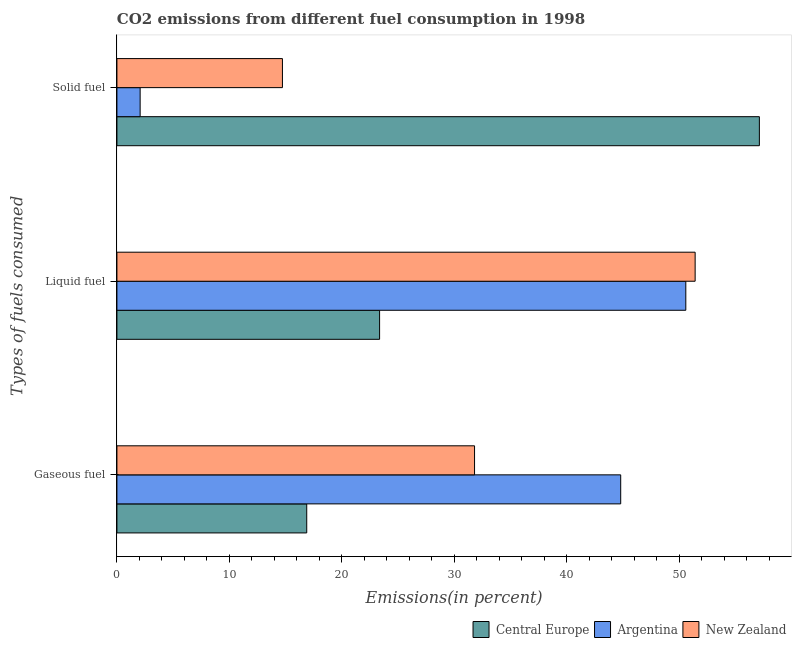How many different coloured bars are there?
Provide a succinct answer. 3. How many groups of bars are there?
Ensure brevity in your answer.  3. Are the number of bars on each tick of the Y-axis equal?
Keep it short and to the point. Yes. How many bars are there on the 1st tick from the top?
Provide a short and direct response. 3. How many bars are there on the 2nd tick from the bottom?
Provide a short and direct response. 3. What is the label of the 3rd group of bars from the top?
Your answer should be very brief. Gaseous fuel. What is the percentage of liquid fuel emission in Argentina?
Your answer should be compact. 50.58. Across all countries, what is the maximum percentage of gaseous fuel emission?
Your answer should be compact. 44.79. Across all countries, what is the minimum percentage of gaseous fuel emission?
Offer a very short reply. 16.88. In which country was the percentage of solid fuel emission minimum?
Offer a very short reply. Argentina. What is the total percentage of gaseous fuel emission in the graph?
Provide a short and direct response. 93.46. What is the difference between the percentage of solid fuel emission in New Zealand and that in Central Europe?
Your answer should be very brief. -42.4. What is the difference between the percentage of gaseous fuel emission in Argentina and the percentage of liquid fuel emission in Central Europe?
Offer a very short reply. 21.44. What is the average percentage of solid fuel emission per country?
Provide a succinct answer. 24.63. What is the difference between the percentage of gaseous fuel emission and percentage of liquid fuel emission in New Zealand?
Keep it short and to the point. -19.61. In how many countries, is the percentage of liquid fuel emission greater than 50 %?
Your response must be concise. 2. What is the ratio of the percentage of solid fuel emission in Central Europe to that in Argentina?
Offer a terse response. 27.67. Is the percentage of solid fuel emission in Argentina less than that in Central Europe?
Keep it short and to the point. Yes. Is the difference between the percentage of liquid fuel emission in Central Europe and Argentina greater than the difference between the percentage of solid fuel emission in Central Europe and Argentina?
Make the answer very short. No. What is the difference between the highest and the second highest percentage of solid fuel emission?
Make the answer very short. 42.4. What is the difference between the highest and the lowest percentage of gaseous fuel emission?
Your answer should be compact. 27.91. Is the sum of the percentage of solid fuel emission in Argentina and Central Europe greater than the maximum percentage of gaseous fuel emission across all countries?
Make the answer very short. Yes. How many bars are there?
Offer a very short reply. 9. Are the values on the major ticks of X-axis written in scientific E-notation?
Offer a very short reply. No. Where does the legend appear in the graph?
Give a very brief answer. Bottom right. How many legend labels are there?
Provide a short and direct response. 3. How are the legend labels stacked?
Give a very brief answer. Horizontal. What is the title of the graph?
Your answer should be compact. CO2 emissions from different fuel consumption in 1998. What is the label or title of the X-axis?
Make the answer very short. Emissions(in percent). What is the label or title of the Y-axis?
Your answer should be very brief. Types of fuels consumed. What is the Emissions(in percent) of Central Europe in Gaseous fuel?
Ensure brevity in your answer.  16.88. What is the Emissions(in percent) in Argentina in Gaseous fuel?
Make the answer very short. 44.79. What is the Emissions(in percent) of New Zealand in Gaseous fuel?
Keep it short and to the point. 31.79. What is the Emissions(in percent) of Central Europe in Liquid fuel?
Keep it short and to the point. 23.35. What is the Emissions(in percent) in Argentina in Liquid fuel?
Offer a terse response. 50.58. What is the Emissions(in percent) in New Zealand in Liquid fuel?
Ensure brevity in your answer.  51.41. What is the Emissions(in percent) of Central Europe in Solid fuel?
Your response must be concise. 57.12. What is the Emissions(in percent) of Argentina in Solid fuel?
Provide a short and direct response. 2.06. What is the Emissions(in percent) of New Zealand in Solid fuel?
Ensure brevity in your answer.  14.72. Across all Types of fuels consumed, what is the maximum Emissions(in percent) in Central Europe?
Give a very brief answer. 57.12. Across all Types of fuels consumed, what is the maximum Emissions(in percent) of Argentina?
Your answer should be very brief. 50.58. Across all Types of fuels consumed, what is the maximum Emissions(in percent) in New Zealand?
Provide a succinct answer. 51.41. Across all Types of fuels consumed, what is the minimum Emissions(in percent) in Central Europe?
Offer a very short reply. 16.88. Across all Types of fuels consumed, what is the minimum Emissions(in percent) of Argentina?
Offer a very short reply. 2.06. Across all Types of fuels consumed, what is the minimum Emissions(in percent) in New Zealand?
Provide a succinct answer. 14.72. What is the total Emissions(in percent) in Central Europe in the graph?
Provide a short and direct response. 97.35. What is the total Emissions(in percent) of Argentina in the graph?
Keep it short and to the point. 97.43. What is the total Emissions(in percent) in New Zealand in the graph?
Provide a succinct answer. 97.92. What is the difference between the Emissions(in percent) in Central Europe in Gaseous fuel and that in Liquid fuel?
Keep it short and to the point. -6.48. What is the difference between the Emissions(in percent) of Argentina in Gaseous fuel and that in Liquid fuel?
Give a very brief answer. -5.79. What is the difference between the Emissions(in percent) of New Zealand in Gaseous fuel and that in Liquid fuel?
Offer a terse response. -19.61. What is the difference between the Emissions(in percent) in Central Europe in Gaseous fuel and that in Solid fuel?
Your answer should be compact. -40.24. What is the difference between the Emissions(in percent) in Argentina in Gaseous fuel and that in Solid fuel?
Your answer should be compact. 42.73. What is the difference between the Emissions(in percent) of New Zealand in Gaseous fuel and that in Solid fuel?
Offer a terse response. 17.08. What is the difference between the Emissions(in percent) in Central Europe in Liquid fuel and that in Solid fuel?
Make the answer very short. -33.77. What is the difference between the Emissions(in percent) in Argentina in Liquid fuel and that in Solid fuel?
Your answer should be very brief. 48.51. What is the difference between the Emissions(in percent) of New Zealand in Liquid fuel and that in Solid fuel?
Provide a short and direct response. 36.69. What is the difference between the Emissions(in percent) of Central Europe in Gaseous fuel and the Emissions(in percent) of Argentina in Liquid fuel?
Provide a succinct answer. -33.7. What is the difference between the Emissions(in percent) of Central Europe in Gaseous fuel and the Emissions(in percent) of New Zealand in Liquid fuel?
Offer a terse response. -34.53. What is the difference between the Emissions(in percent) in Argentina in Gaseous fuel and the Emissions(in percent) in New Zealand in Liquid fuel?
Make the answer very short. -6.62. What is the difference between the Emissions(in percent) of Central Europe in Gaseous fuel and the Emissions(in percent) of Argentina in Solid fuel?
Offer a terse response. 14.81. What is the difference between the Emissions(in percent) in Central Europe in Gaseous fuel and the Emissions(in percent) in New Zealand in Solid fuel?
Offer a terse response. 2.16. What is the difference between the Emissions(in percent) in Argentina in Gaseous fuel and the Emissions(in percent) in New Zealand in Solid fuel?
Provide a short and direct response. 30.07. What is the difference between the Emissions(in percent) in Central Europe in Liquid fuel and the Emissions(in percent) in Argentina in Solid fuel?
Provide a short and direct response. 21.29. What is the difference between the Emissions(in percent) of Central Europe in Liquid fuel and the Emissions(in percent) of New Zealand in Solid fuel?
Your answer should be compact. 8.64. What is the difference between the Emissions(in percent) of Argentina in Liquid fuel and the Emissions(in percent) of New Zealand in Solid fuel?
Provide a short and direct response. 35.86. What is the average Emissions(in percent) of Central Europe per Types of fuels consumed?
Provide a short and direct response. 32.45. What is the average Emissions(in percent) in Argentina per Types of fuels consumed?
Your answer should be compact. 32.48. What is the average Emissions(in percent) in New Zealand per Types of fuels consumed?
Provide a short and direct response. 32.64. What is the difference between the Emissions(in percent) in Central Europe and Emissions(in percent) in Argentina in Gaseous fuel?
Provide a short and direct response. -27.91. What is the difference between the Emissions(in percent) of Central Europe and Emissions(in percent) of New Zealand in Gaseous fuel?
Your answer should be very brief. -14.92. What is the difference between the Emissions(in percent) of Argentina and Emissions(in percent) of New Zealand in Gaseous fuel?
Offer a terse response. 13. What is the difference between the Emissions(in percent) in Central Europe and Emissions(in percent) in Argentina in Liquid fuel?
Offer a very short reply. -27.23. What is the difference between the Emissions(in percent) in Central Europe and Emissions(in percent) in New Zealand in Liquid fuel?
Provide a short and direct response. -28.05. What is the difference between the Emissions(in percent) in Argentina and Emissions(in percent) in New Zealand in Liquid fuel?
Provide a succinct answer. -0.83. What is the difference between the Emissions(in percent) in Central Europe and Emissions(in percent) in Argentina in Solid fuel?
Ensure brevity in your answer.  55.05. What is the difference between the Emissions(in percent) of Central Europe and Emissions(in percent) of New Zealand in Solid fuel?
Give a very brief answer. 42.4. What is the difference between the Emissions(in percent) of Argentina and Emissions(in percent) of New Zealand in Solid fuel?
Make the answer very short. -12.65. What is the ratio of the Emissions(in percent) of Central Europe in Gaseous fuel to that in Liquid fuel?
Give a very brief answer. 0.72. What is the ratio of the Emissions(in percent) of Argentina in Gaseous fuel to that in Liquid fuel?
Offer a terse response. 0.89. What is the ratio of the Emissions(in percent) of New Zealand in Gaseous fuel to that in Liquid fuel?
Keep it short and to the point. 0.62. What is the ratio of the Emissions(in percent) in Central Europe in Gaseous fuel to that in Solid fuel?
Your answer should be compact. 0.3. What is the ratio of the Emissions(in percent) in Argentina in Gaseous fuel to that in Solid fuel?
Give a very brief answer. 21.7. What is the ratio of the Emissions(in percent) in New Zealand in Gaseous fuel to that in Solid fuel?
Provide a succinct answer. 2.16. What is the ratio of the Emissions(in percent) in Central Europe in Liquid fuel to that in Solid fuel?
Your answer should be very brief. 0.41. What is the ratio of the Emissions(in percent) of Argentina in Liquid fuel to that in Solid fuel?
Keep it short and to the point. 24.5. What is the ratio of the Emissions(in percent) in New Zealand in Liquid fuel to that in Solid fuel?
Provide a succinct answer. 3.49. What is the difference between the highest and the second highest Emissions(in percent) of Central Europe?
Make the answer very short. 33.77. What is the difference between the highest and the second highest Emissions(in percent) in Argentina?
Offer a terse response. 5.79. What is the difference between the highest and the second highest Emissions(in percent) of New Zealand?
Your answer should be very brief. 19.61. What is the difference between the highest and the lowest Emissions(in percent) of Central Europe?
Provide a succinct answer. 40.24. What is the difference between the highest and the lowest Emissions(in percent) in Argentina?
Ensure brevity in your answer.  48.51. What is the difference between the highest and the lowest Emissions(in percent) in New Zealand?
Offer a very short reply. 36.69. 